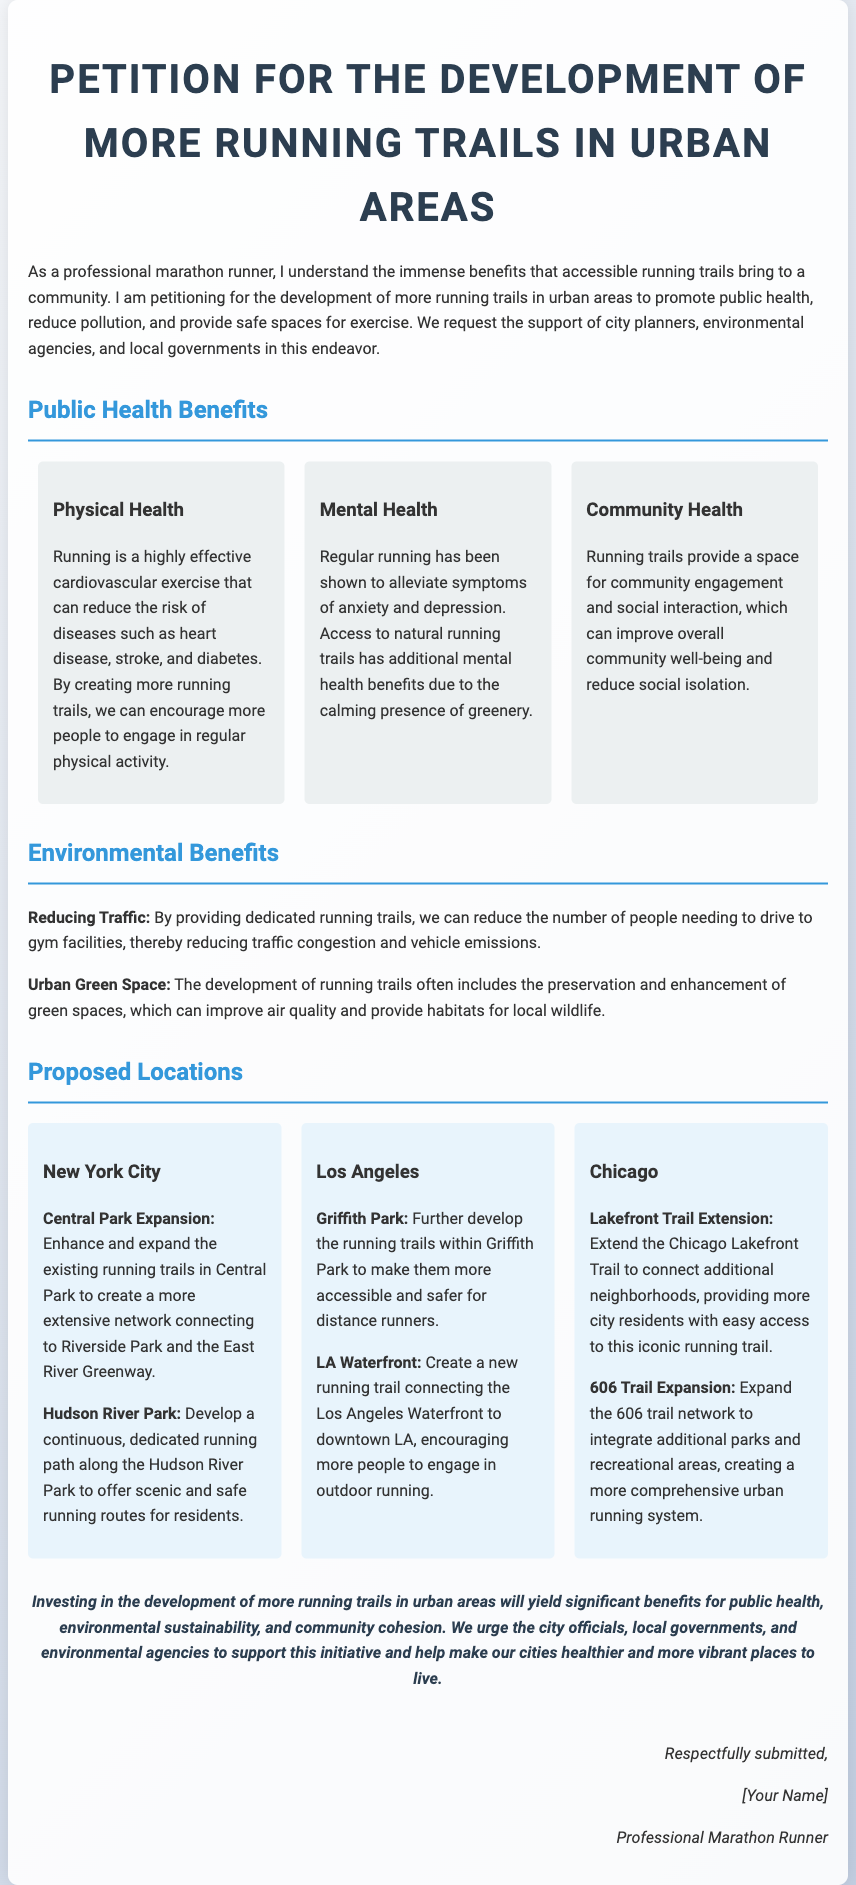What is the title of the petition? The title of the petition is stated at the top of the document.
Answer: Petition for the Development of More Running Trails in Urban Areas What are the three types of public health benefits mentioned? The document lists the physical, mental, and community health benefits in separate sections.
Answer: Physical Health, Mental Health, Community Health Which city is mentioned for the potential expansion of the 606 trail? The document lists specific cities along with proposed locations for running trails, including where the 606 trail is located.
Answer: Chicago What is the proposed enhancement for Central Park? The petition describes specific improvements planned for Central Park’s running trails.
Answer: Enhance and expand the existing running trails What is one key environmental benefit mentioned in the petition? The document outlines several environmental advantages associated with developing running trails.
Answer: Reducing Traffic How does the petition describe running's impact on mental health? The petition provides a specific claim about running and its psychological benefits.
Answer: Alleviate symptoms of anxiety and depression What is the purpose of this petition? The first paragraph of the document summarizes the main goal of the petition.
Answer: To promote public health and safe spaces for exercise Which California location is proposed for new running trails? The document specifies locations in Los Angeles that are suggested for trail development.
Answer: Griffith Park What is the concluding statement of the petition? The conclusion summarizes the overall plea made in the petition.
Answer: Investing in the development of more running trails in urban areas will yield significant benefits for public health, environmental sustainability, and community cohesion 